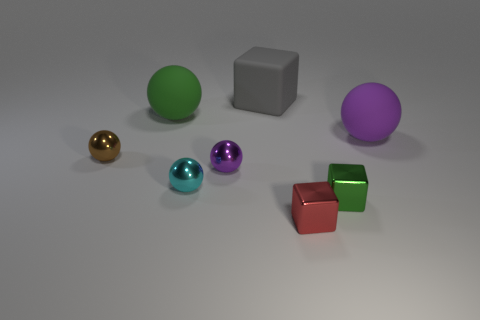Is there a small red block made of the same material as the tiny green cube?
Keep it short and to the point. Yes. What color is the rubber ball on the right side of the big green thing?
Your answer should be compact. Purple. Is the shape of the tiny green object the same as the tiny red metal thing in front of the purple matte thing?
Your answer should be very brief. Yes. There is a purple ball that is the same material as the big green ball; what is its size?
Offer a terse response. Large. There is a purple object left of the purple matte object; is it the same shape as the red object?
Your answer should be very brief. No. What number of brown metallic spheres have the same size as the green shiny cube?
Your response must be concise. 1. Are there any large green spheres to the left of the sphere to the right of the large matte cube?
Make the answer very short. Yes. How many things are either large objects that are in front of the big gray object or gray objects?
Provide a succinct answer. 3. How many tiny shiny spheres are there?
Offer a very short reply. 3. There is a small purple object that is made of the same material as the small cyan ball; what is its shape?
Give a very brief answer. Sphere. 